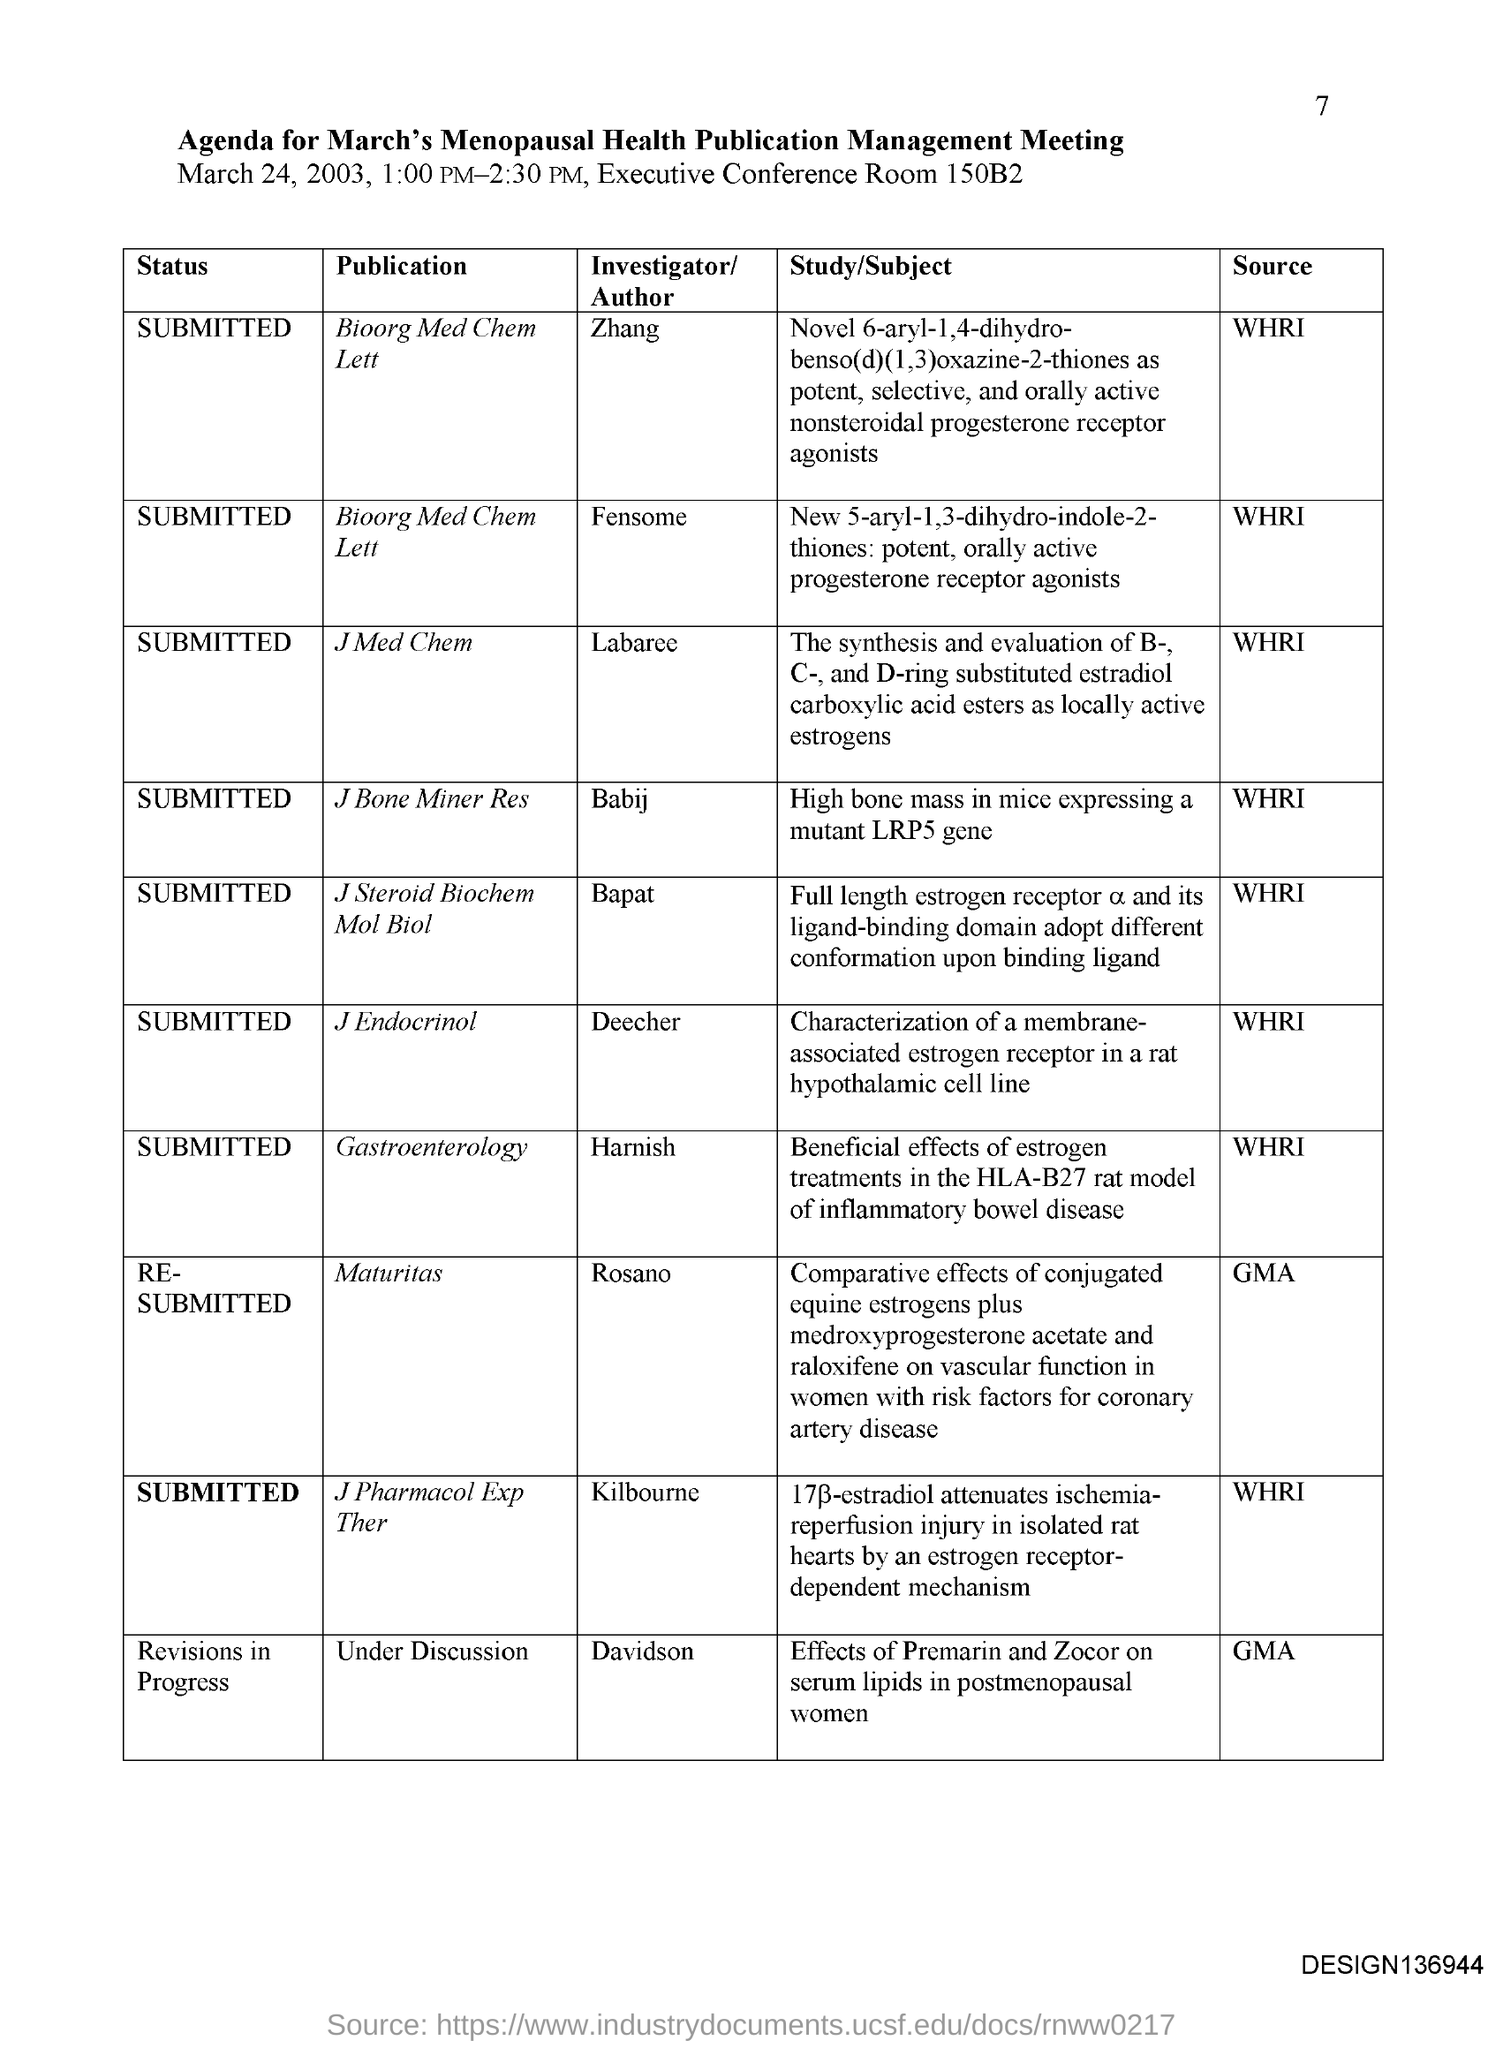What other studies were submitted for the same publication management meeting? Aside from the study involving high bone mass in mice, the agenda lists several other submitted studies for review. These include research on novel compounds acting on steroid receptors, an evaluation of estradiol derivatives, analysis of full-length estrogen receptor conformation changes, and insights into the effects of steroidal treatments in different medical conditions. All these studies contribute to a deeper understanding of hormonal impacts on health. 